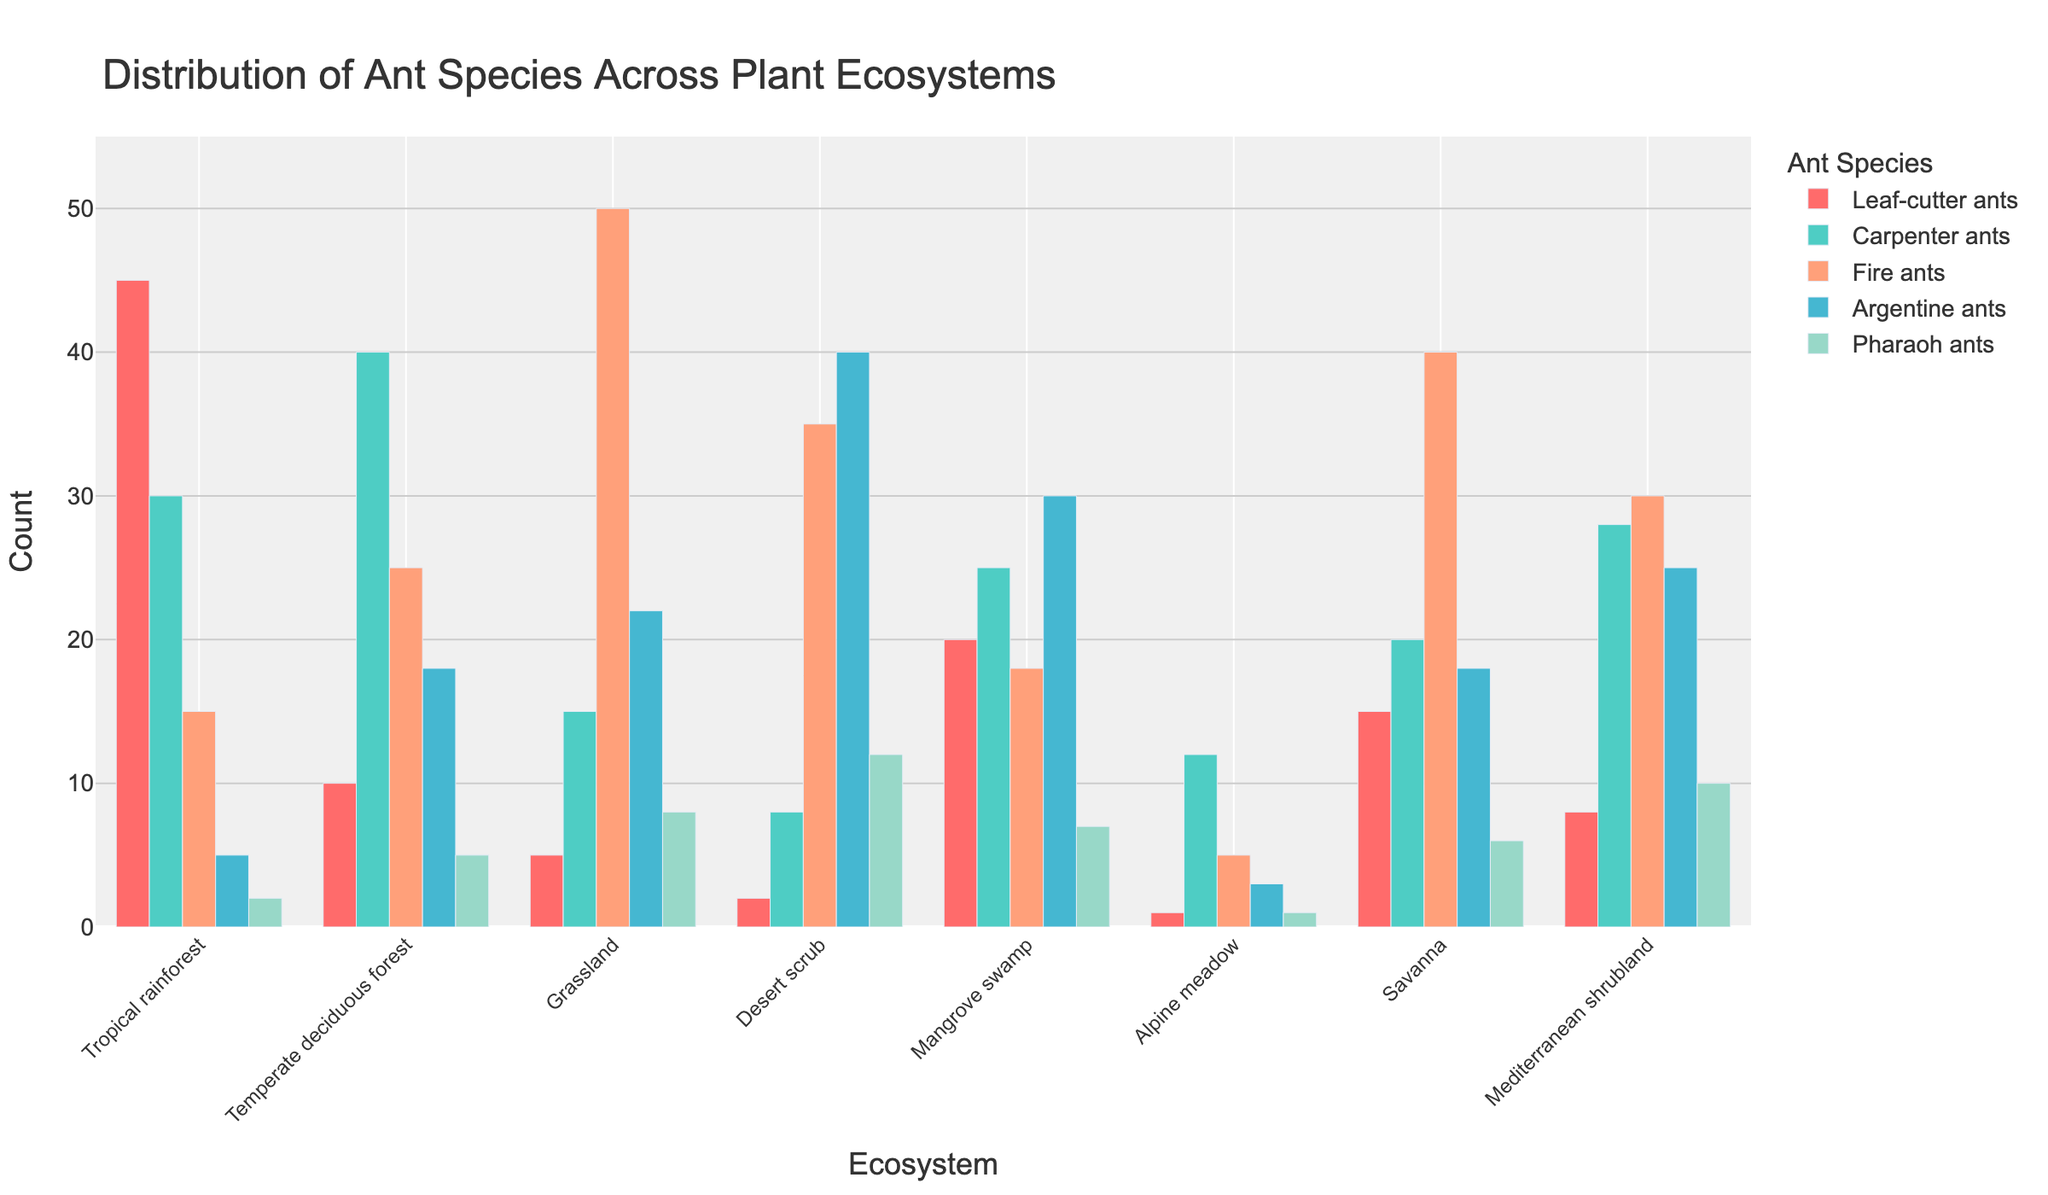Which ecosystem has the highest count of Leaf-cutter ants? Look at the Leaf-cutter ants' bars and compare their heights across all ecosystems, the tallest bar represents the highest count. In this case, it's the Tropical rainforest.
Answer: Tropical rainforest Which ant species is the most abundant in the Grassland ecosystem? Examine the Grassland section of the chart and identify the tallest bar. The Fire ants' bar is the tallest, indicating they are the most abundant species in the Grassland ecosystem.
Answer: Fire ants What is the total count of ants in the Alpine meadow ecosystem? Sum the counts of all ant species in the Alpine meadow ecosystem: 1 (Leaf-cutter ants) + 12 (Carpenter ants) + 5 (Fire ants) + 3 (Argentine ants) + 1 (Pharaoh ants). The total is 22.
Answer: 22 Which ecosystem has the lowest count of Argentine ants? Compare the heights of the Argentine ants' bars across all ecosystems. The shortest bar belongs to the Alpine meadow ecosystem with a count of 3.
Answer: Alpine meadow What is the combined count of Fire ants and Pharaoh ants in the Desert scrub ecosystem? Add the counts of Fire ants (35) and Pharaoh ants (12) in the Desert scrub ecosystem. The combined count is 47.
Answer: 47 How does the count of Carpenter ants in the Temperate deciduous forest compare to the count of Leaf-cutter ants in the same ecosystem? The Carpenter ants count in the Temperate deciduous forest is 40, while the Leaf-cutter ants count is 10. Comparing the two, Carpenter ants are more numerous.
Answer: Carpenter ants are more numerous What is the average count of Fire ants across all ecosystems? Sum the counts of Fire ants across all ecosystems: 15 (Tropical rainforest) + 25 (Temperate deciduous forest) + 50 (Grassland) + 35 (Desert scrub) + 18 (Mangrove swamp) + 5 (Alpine meadow) + 40 (Savanna) + 30 (Mediterranean shrubland). The total is 218. Divide by the number of ecosystems (8) to find the average: 218 / 8 = 27.25.
Answer: 27.25 Which ecosystem has the second highest count of Argentine ants? Compare the Argentine ants' bars across all ecosystems and find the second tallest bar. The tallest is in the Desert scrub (40), and the second tallest is in the Mangrove swamp (30).
Answer: Mangrove swamp 